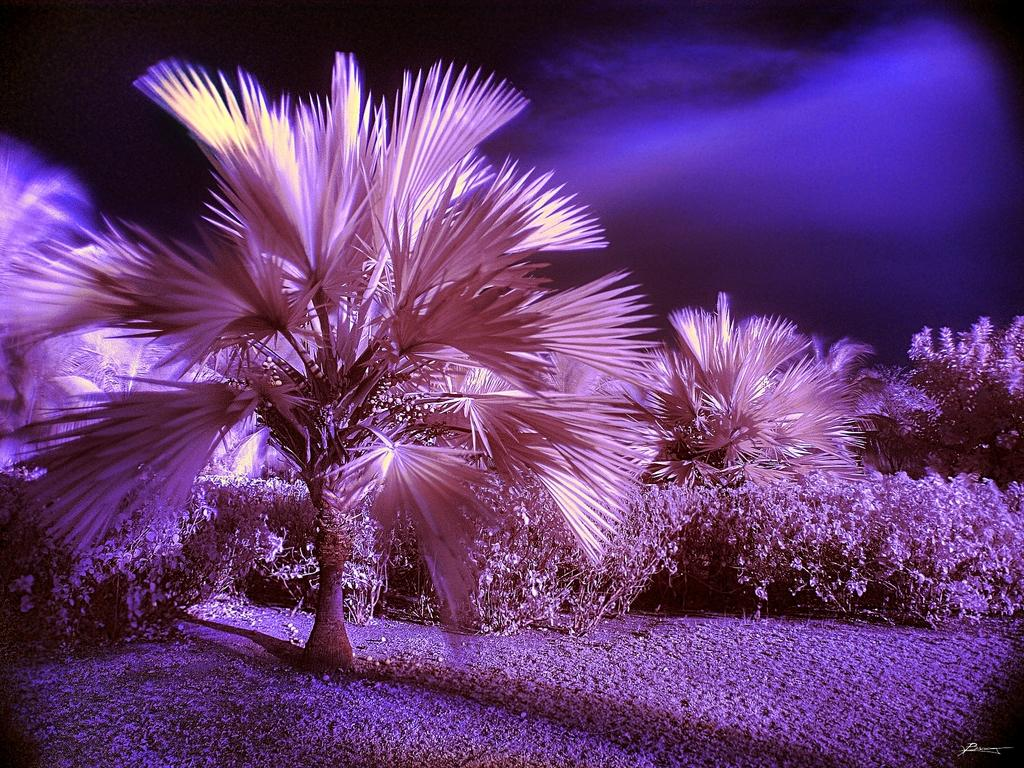What type of living organisms can be seen in the image? Plants and trees are visible in the image. Can you describe the background of the image? The background of the image is dark. What type of popcorn is being served to the daughter in the image? There is no daughter or popcorn present in the image; it only features plants and trees. 